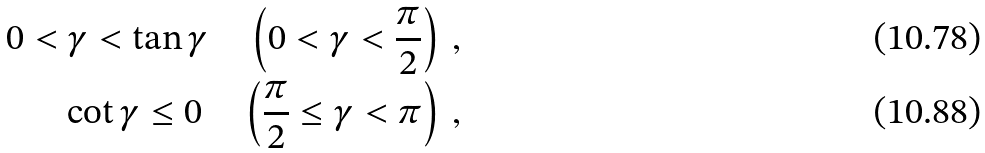<formula> <loc_0><loc_0><loc_500><loc_500>0 < \gamma < \tan \gamma \quad \left ( 0 < \gamma < \frac { \pi } { 2 } \right ) \, , \\ \cot \gamma \leq 0 \quad \left ( \frac { \pi } { 2 } \leq \gamma < \pi \right ) \, ,</formula> 